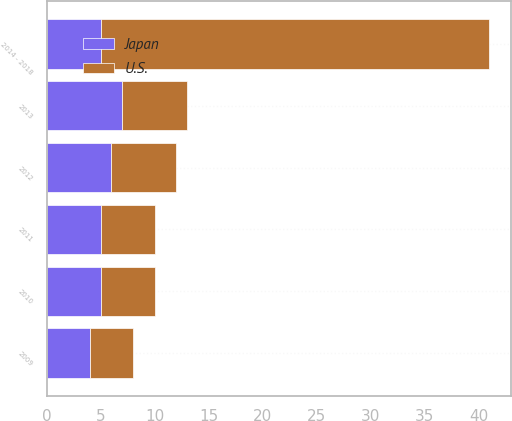Convert chart to OTSL. <chart><loc_0><loc_0><loc_500><loc_500><stacked_bar_chart><ecel><fcel>2009<fcel>2010<fcel>2011<fcel>2012<fcel>2013<fcel>2014 - 2018<nl><fcel>U.S.<fcel>4<fcel>5<fcel>5<fcel>6<fcel>6<fcel>36<nl><fcel>Japan<fcel>4<fcel>5<fcel>5<fcel>6<fcel>7<fcel>5<nl></chart> 